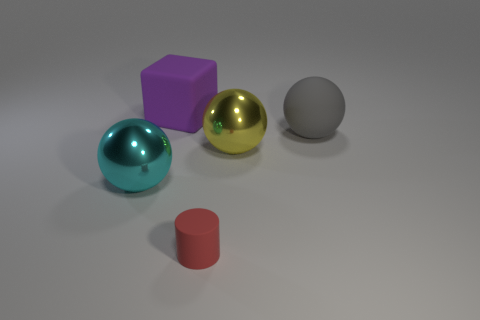What time of day or lighting conditions does the environment suggest? The lighting conditions in the image appear to be neutral, with no strong indicators of a specific time of day. The soft, diffused shadows suggest an artificial or studio light setup, designed to minimize harsh shadows and evenly illuminate the objects. 